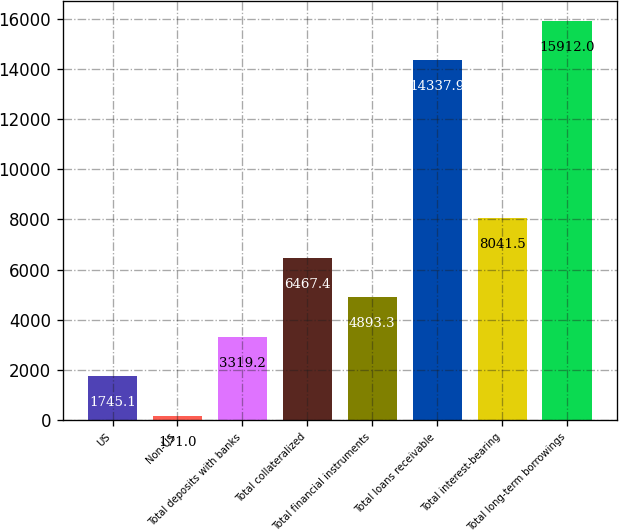Convert chart. <chart><loc_0><loc_0><loc_500><loc_500><bar_chart><fcel>US<fcel>Non-US<fcel>Total deposits with banks<fcel>Total collateralized<fcel>Total financial instruments<fcel>Total loans receivable<fcel>Total interest-bearing<fcel>Total long-term borrowings<nl><fcel>1745.1<fcel>171<fcel>3319.2<fcel>6467.4<fcel>4893.3<fcel>14337.9<fcel>8041.5<fcel>15912<nl></chart> 